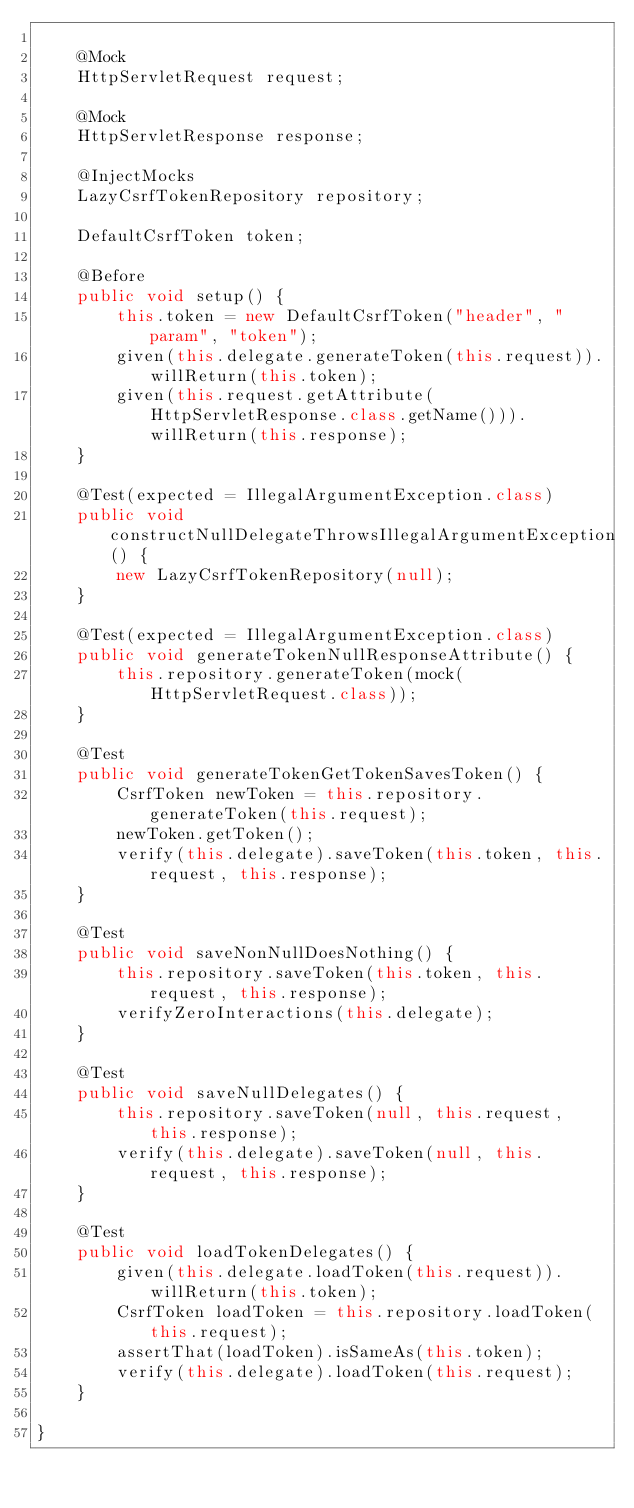Convert code to text. <code><loc_0><loc_0><loc_500><loc_500><_Java_>
	@Mock
	HttpServletRequest request;

	@Mock
	HttpServletResponse response;

	@InjectMocks
	LazyCsrfTokenRepository repository;

	DefaultCsrfToken token;

	@Before
	public void setup() {
		this.token = new DefaultCsrfToken("header", "param", "token");
		given(this.delegate.generateToken(this.request)).willReturn(this.token);
		given(this.request.getAttribute(HttpServletResponse.class.getName())).willReturn(this.response);
	}

	@Test(expected = IllegalArgumentException.class)
	public void constructNullDelegateThrowsIllegalArgumentException() {
		new LazyCsrfTokenRepository(null);
	}

	@Test(expected = IllegalArgumentException.class)
	public void generateTokenNullResponseAttribute() {
		this.repository.generateToken(mock(HttpServletRequest.class));
	}

	@Test
	public void generateTokenGetTokenSavesToken() {
		CsrfToken newToken = this.repository.generateToken(this.request);
		newToken.getToken();
		verify(this.delegate).saveToken(this.token, this.request, this.response);
	}

	@Test
	public void saveNonNullDoesNothing() {
		this.repository.saveToken(this.token, this.request, this.response);
		verifyZeroInteractions(this.delegate);
	}

	@Test
	public void saveNullDelegates() {
		this.repository.saveToken(null, this.request, this.response);
		verify(this.delegate).saveToken(null, this.request, this.response);
	}

	@Test
	public void loadTokenDelegates() {
		given(this.delegate.loadToken(this.request)).willReturn(this.token);
		CsrfToken loadToken = this.repository.loadToken(this.request);
		assertThat(loadToken).isSameAs(this.token);
		verify(this.delegate).loadToken(this.request);
	}

}
</code> 